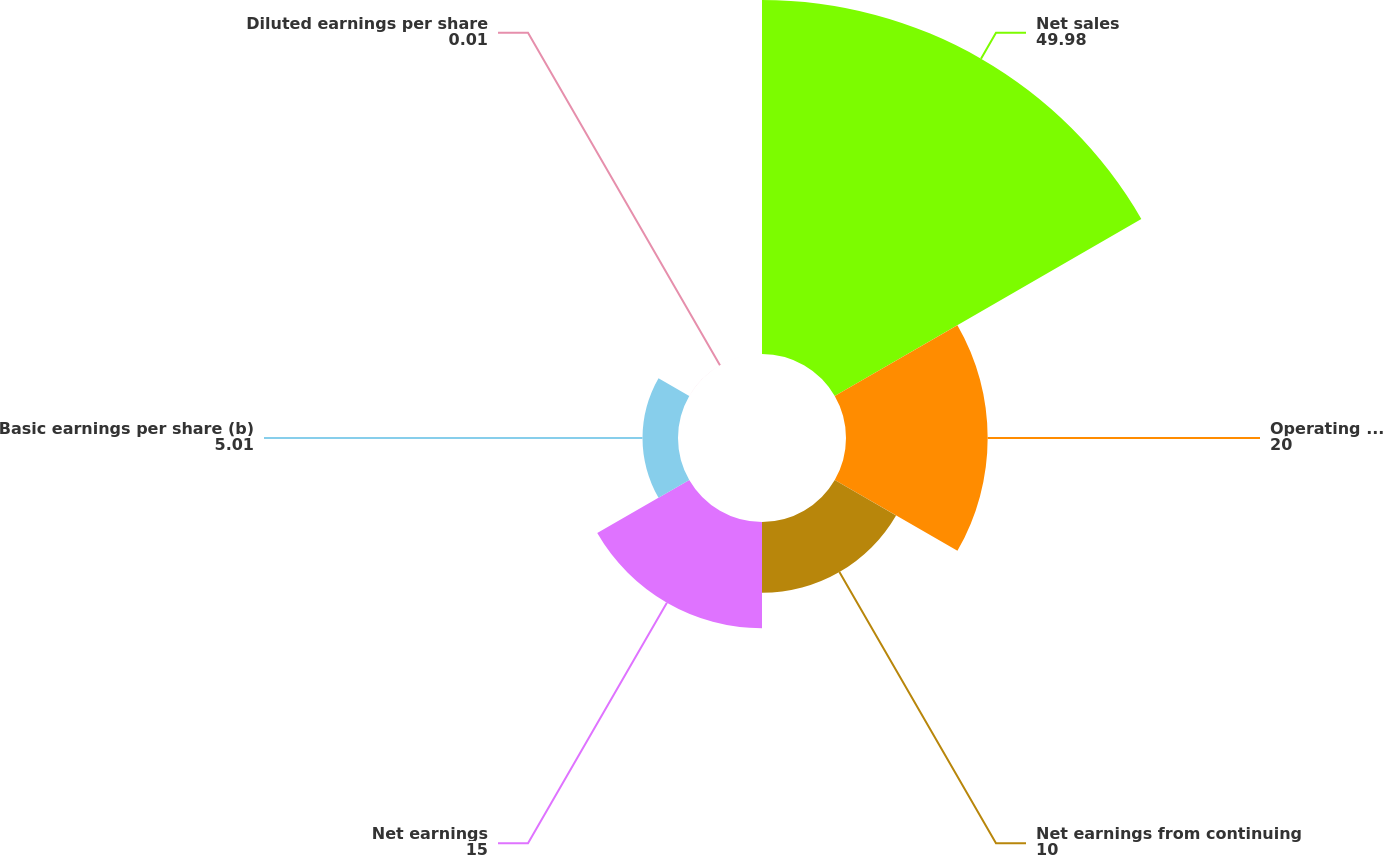Convert chart. <chart><loc_0><loc_0><loc_500><loc_500><pie_chart><fcel>Net sales<fcel>Operating profit<fcel>Net earnings from continuing<fcel>Net earnings<fcel>Basic earnings per share (b)<fcel>Diluted earnings per share<nl><fcel>49.98%<fcel>20.0%<fcel>10.0%<fcel>15.0%<fcel>5.01%<fcel>0.01%<nl></chart> 